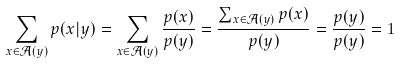<formula> <loc_0><loc_0><loc_500><loc_500>\sum _ { x \in \mathcal { A } ( y ) } p ( x | y ) = \sum _ { x \in \mathcal { A } ( y ) } \frac { p ( x ) } { p ( y ) } = \frac { \sum _ { x \in \mathcal { A } ( y ) } p ( x ) } { p ( y ) } = \frac { p ( y ) } { p ( y ) } = 1</formula> 